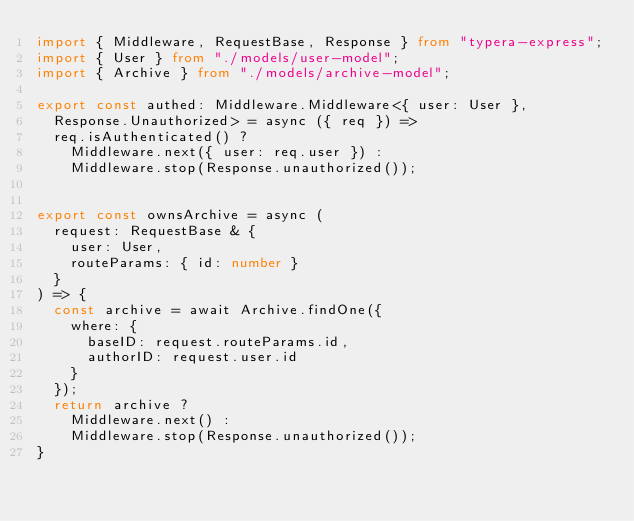Convert code to text. <code><loc_0><loc_0><loc_500><loc_500><_TypeScript_>import { Middleware, RequestBase, Response } from "typera-express";
import { User } from "./models/user-model";
import { Archive } from "./models/archive-model";

export const authed: Middleware.Middleware<{ user: User },
  Response.Unauthorized> = async ({ req }) =>
  req.isAuthenticated() ?
    Middleware.next({ user: req.user }) :
    Middleware.stop(Response.unauthorized());


export const ownsArchive = async (
  request: RequestBase & {
    user: User,
    routeParams: { id: number }
  }
) => {
  const archive = await Archive.findOne({
    where: {
      baseID: request.routeParams.id,
      authorID: request.user.id
    }
  });
  return archive ?
    Middleware.next() :
    Middleware.stop(Response.unauthorized());
}
</code> 